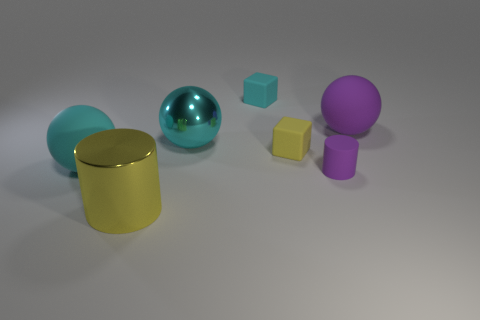There is a object that is the same color as the big cylinder; what shape is it?
Give a very brief answer. Cube. Is the material of the big object on the left side of the big yellow cylinder the same as the large cyan object that is behind the big cyan rubber ball?
Offer a terse response. No. There is a ball that is the same color as the rubber cylinder; what material is it?
Your answer should be very brief. Rubber. How many tiny purple objects have the same shape as the small cyan matte thing?
Your answer should be compact. 0. Does the cyan block have the same material as the yellow object behind the big cyan rubber ball?
Your response must be concise. Yes. There is a yellow thing that is the same size as the cyan rubber sphere; what material is it?
Give a very brief answer. Metal. Is there a purple matte ball of the same size as the cyan matte sphere?
Your response must be concise. Yes. There is a yellow thing that is the same size as the purple sphere; what is its shape?
Offer a terse response. Cylinder. What number of other things are the same color as the rubber cylinder?
Your response must be concise. 1. The rubber thing that is in front of the big purple matte object and on the right side of the small yellow object has what shape?
Your answer should be very brief. Cylinder. 